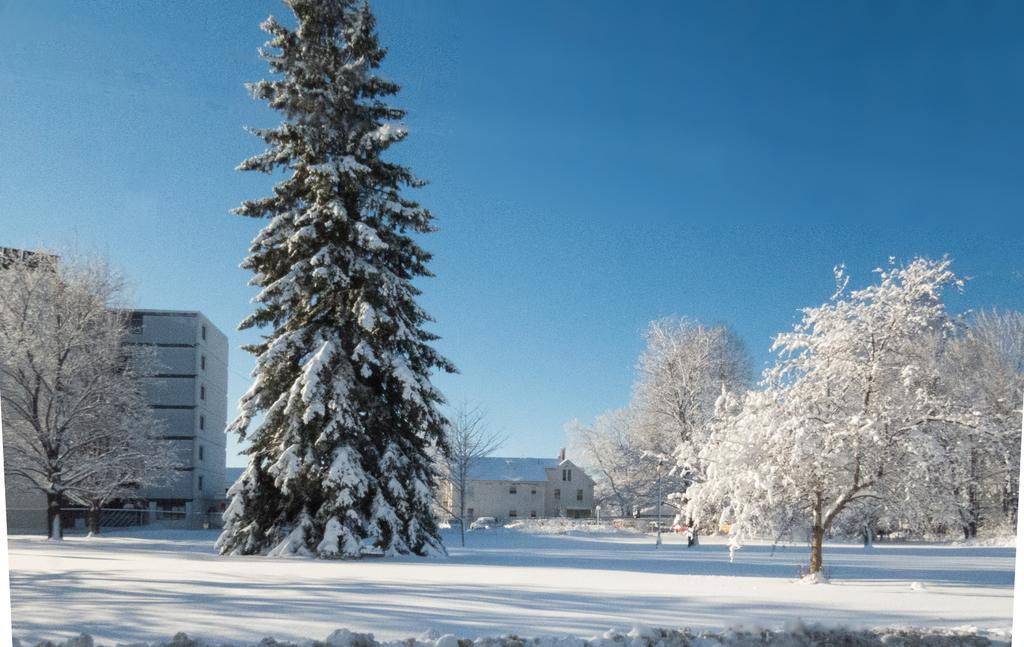What type of structures can be seen in the image? There are buildings in the image. What natural elements are present in the image? There are trees in the image. What man-made objects can be seen in the image? There are poles in the image. What is the weather like in the image? Snow is present on the trees and visible at the bottom of the image, indicating a snowy environment. What else can be seen in the image? There is a vehicle in the image. What is visible at the top of the image? The sky is visible at the top of the image. What type of pancake is being served at the son's birthday party in the image? There is no son or birthday party present in the image, and therefore no pancakes can be observed. What boundary is depicted between the buildings and the trees in the image? There is no boundary depicted between the buildings and the trees in the image; they are simply located in the same scene. 